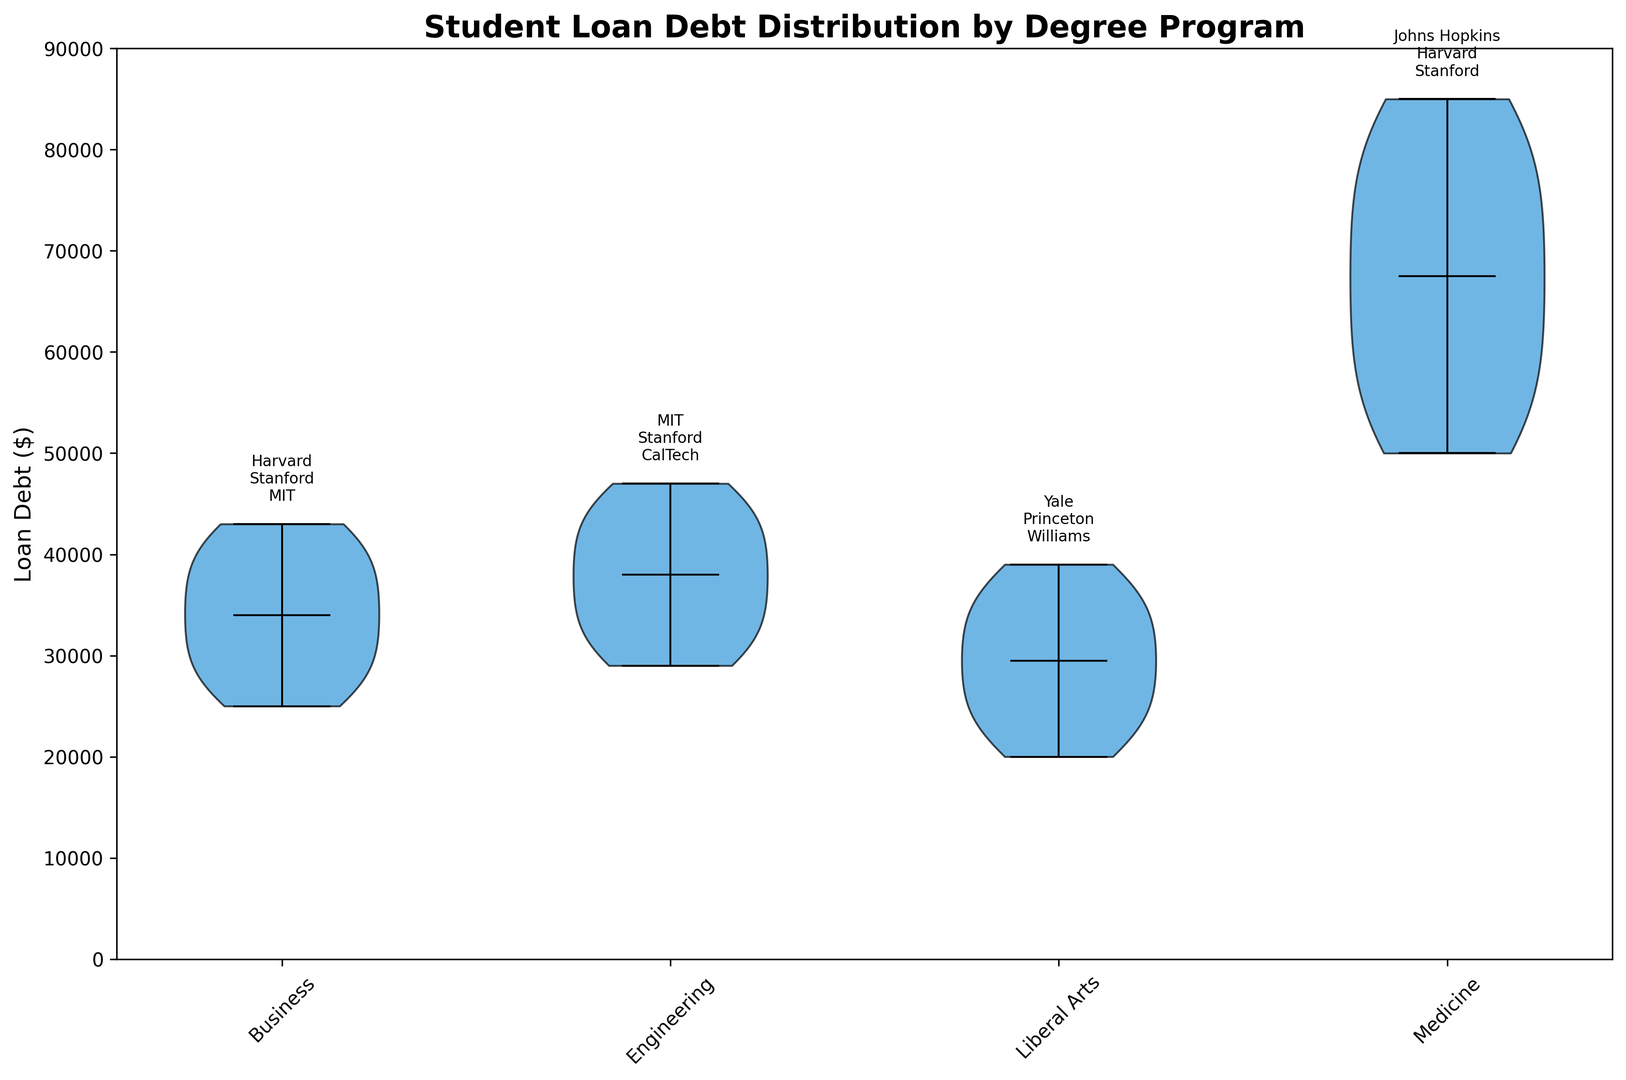How many degree programs have loan debt distributions with an upper range above $80,000? The upper ranges can be identified by the top of the violin plots. Only Medicine has an upper range above $80,000, consistent with the visible data distribution.
Answer: 1 Which university has the highest median loan debt in the Medicine program? Identify the median markers (horizontal lines within the violins) for the Medicine program and determine the highest value. Stanford's median lies higher than Johns Hopkins and Harvard.
Answer: Stanford In which degree program is the loan debt distribution the widest? A wide distribution shows a larger spread in the violin plot. Medicine clearly has the widest span from lowest to highest loan debt among the programs.
Answer: Medicine Which program has the lowest range of loan debts? The lowest range can be visualized by comparing the range between the bottom and top of the violins. Liberal Arts has the smallest range.
Answer: Liberal Arts What’s the median loan debt for the Engineering program at Stanford? Median values are represented by horizontal lines within the violins. The median for Stanford Engineering lies approximately at $37,000.
Answer: $37,000 Compare the median loan debt for Engineering programs at MIT and Stanford. Which is higher? Locate the medians within the Engineering violin plots for MIT and Stanford. MIT’s median is slightly lower than Stanford’s.
Answer: Stanford Which university has the lowest loan debt distribution in the Liberal Arts program? The lowest distribution can be identified by the bottom end of the violin plots in the Liberal Arts section. Williams shows the lowest range.
Answer: Williams If you consider only the universities within the Liberal Arts program, which one has the highest median debt? Compare the median indicators across the universities in the Liberal Arts program. Princeton has the highest median debt.
Answer: Princeton Which degree program shows the most significant difference between the highest and lowest median loan debts? Compare the median values across all programs and identify the largest range. Medicine shows the most pronounced difference.
Answer: Medicine What’s the range of loan debt for the Business program at Harvard? Identify the top and bottom of the Business violin plot for Harvard. The smallest and largest values are $25,000 and $40,000, respectively, so the range is $15,000.
Answer: $15,000 